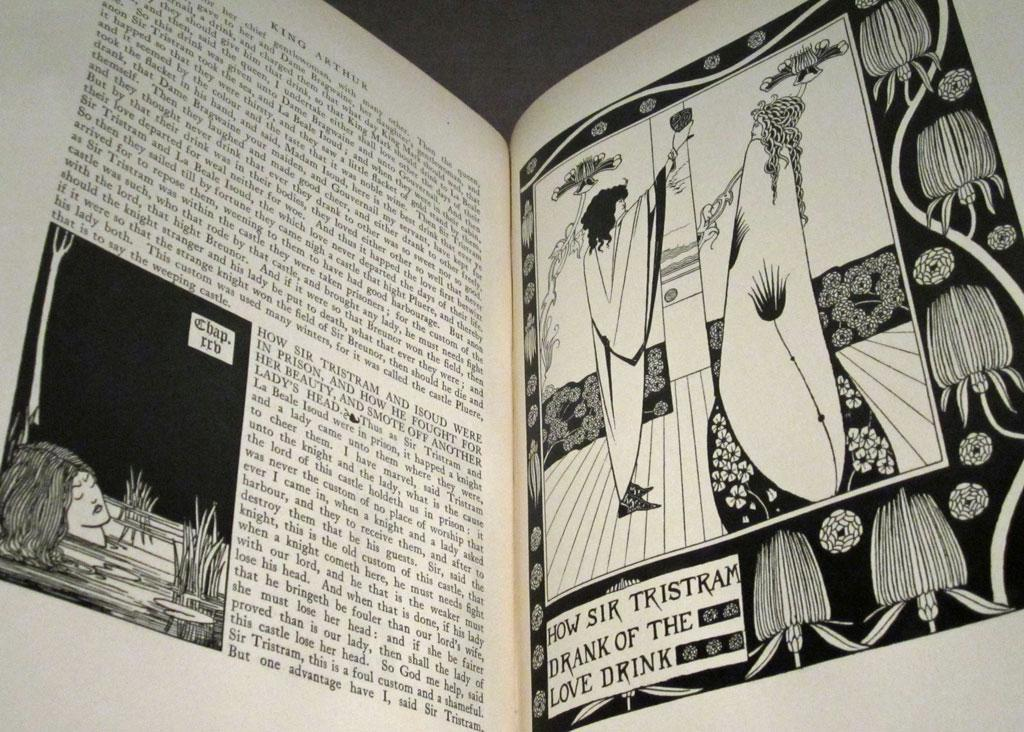<image>
Provide a brief description of the given image. a couple pages from a book and the word Tristram is prominent 